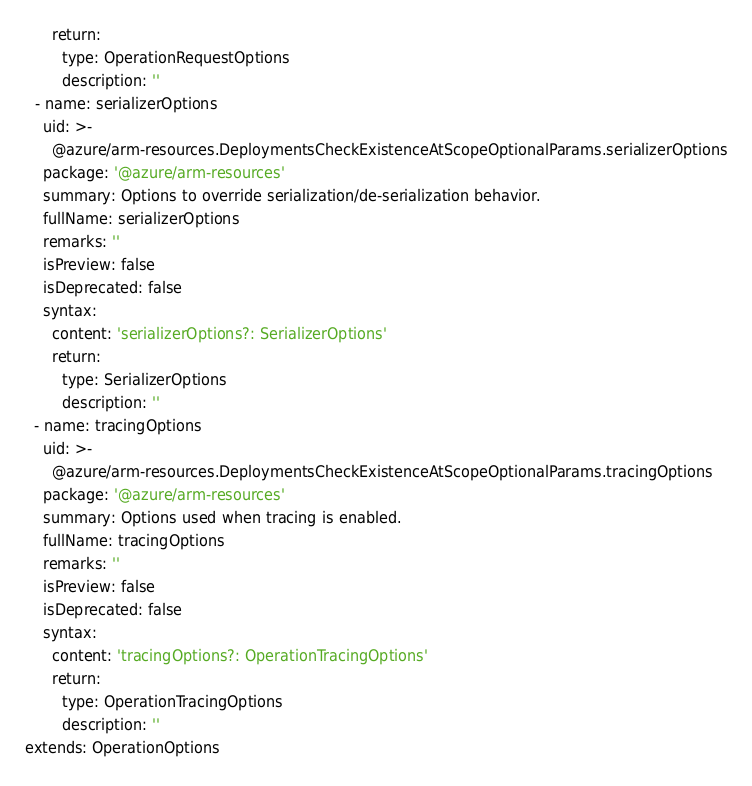Convert code to text. <code><loc_0><loc_0><loc_500><loc_500><_YAML_>      return:
        type: OperationRequestOptions
        description: ''
  - name: serializerOptions
    uid: >-
      @azure/arm-resources.DeploymentsCheckExistenceAtScopeOptionalParams.serializerOptions
    package: '@azure/arm-resources'
    summary: Options to override serialization/de-serialization behavior.
    fullName: serializerOptions
    remarks: ''
    isPreview: false
    isDeprecated: false
    syntax:
      content: 'serializerOptions?: SerializerOptions'
      return:
        type: SerializerOptions
        description: ''
  - name: tracingOptions
    uid: >-
      @azure/arm-resources.DeploymentsCheckExistenceAtScopeOptionalParams.tracingOptions
    package: '@azure/arm-resources'
    summary: Options used when tracing is enabled.
    fullName: tracingOptions
    remarks: ''
    isPreview: false
    isDeprecated: false
    syntax:
      content: 'tracingOptions?: OperationTracingOptions'
      return:
        type: OperationTracingOptions
        description: ''
extends: OperationOptions
</code> 